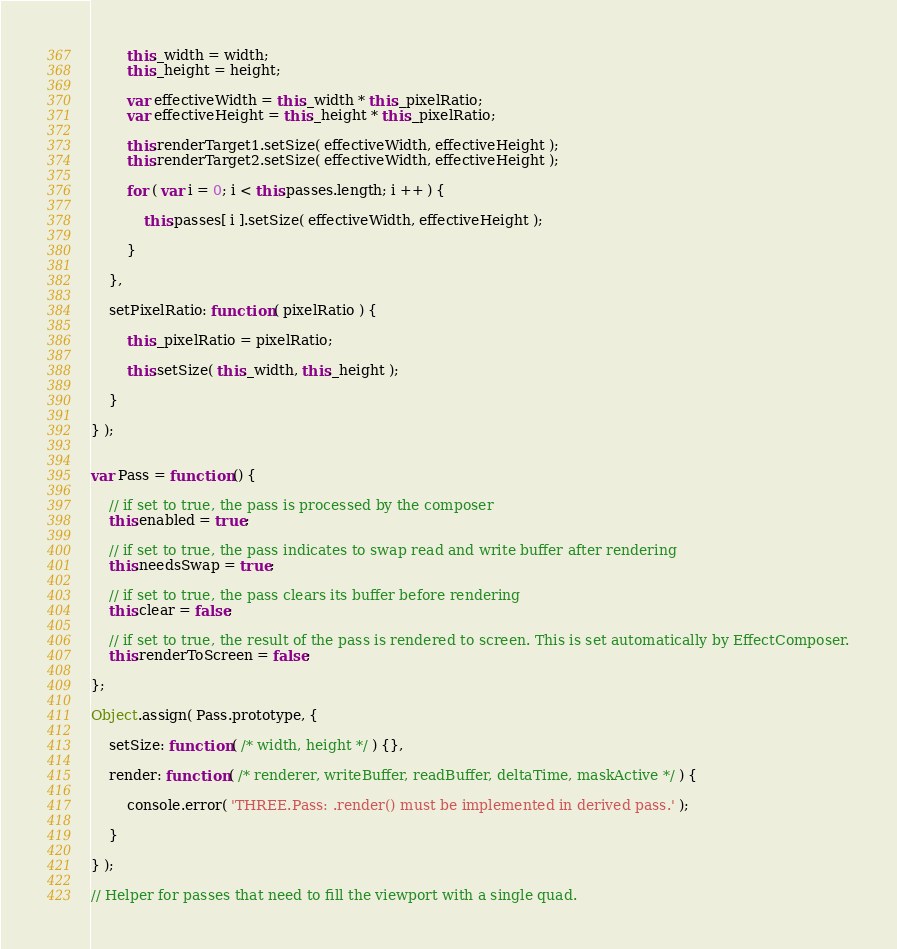Convert code to text. <code><loc_0><loc_0><loc_500><loc_500><_JavaScript_>		this._width = width;
		this._height = height;

		var effectiveWidth = this._width * this._pixelRatio;
		var effectiveHeight = this._height * this._pixelRatio;

		this.renderTarget1.setSize( effectiveWidth, effectiveHeight );
		this.renderTarget2.setSize( effectiveWidth, effectiveHeight );

		for ( var i = 0; i < this.passes.length; i ++ ) {

			this.passes[ i ].setSize( effectiveWidth, effectiveHeight );

		}

	},

	setPixelRatio: function ( pixelRatio ) {

		this._pixelRatio = pixelRatio;

		this.setSize( this._width, this._height );

	}

} );


var Pass = function () {

	// if set to true, the pass is processed by the composer
	this.enabled = true;

	// if set to true, the pass indicates to swap read and write buffer after rendering
	this.needsSwap = true;

	// if set to true, the pass clears its buffer before rendering
	this.clear = false;

	// if set to true, the result of the pass is rendered to screen. This is set automatically by EffectComposer.
	this.renderToScreen = false;

};

Object.assign( Pass.prototype, {

	setSize: function ( /* width, height */ ) {},

	render: function ( /* renderer, writeBuffer, readBuffer, deltaTime, maskActive */ ) {

		console.error( 'THREE.Pass: .render() must be implemented in derived pass.' );

	}

} );

// Helper for passes that need to fill the viewport with a single quad.</code> 